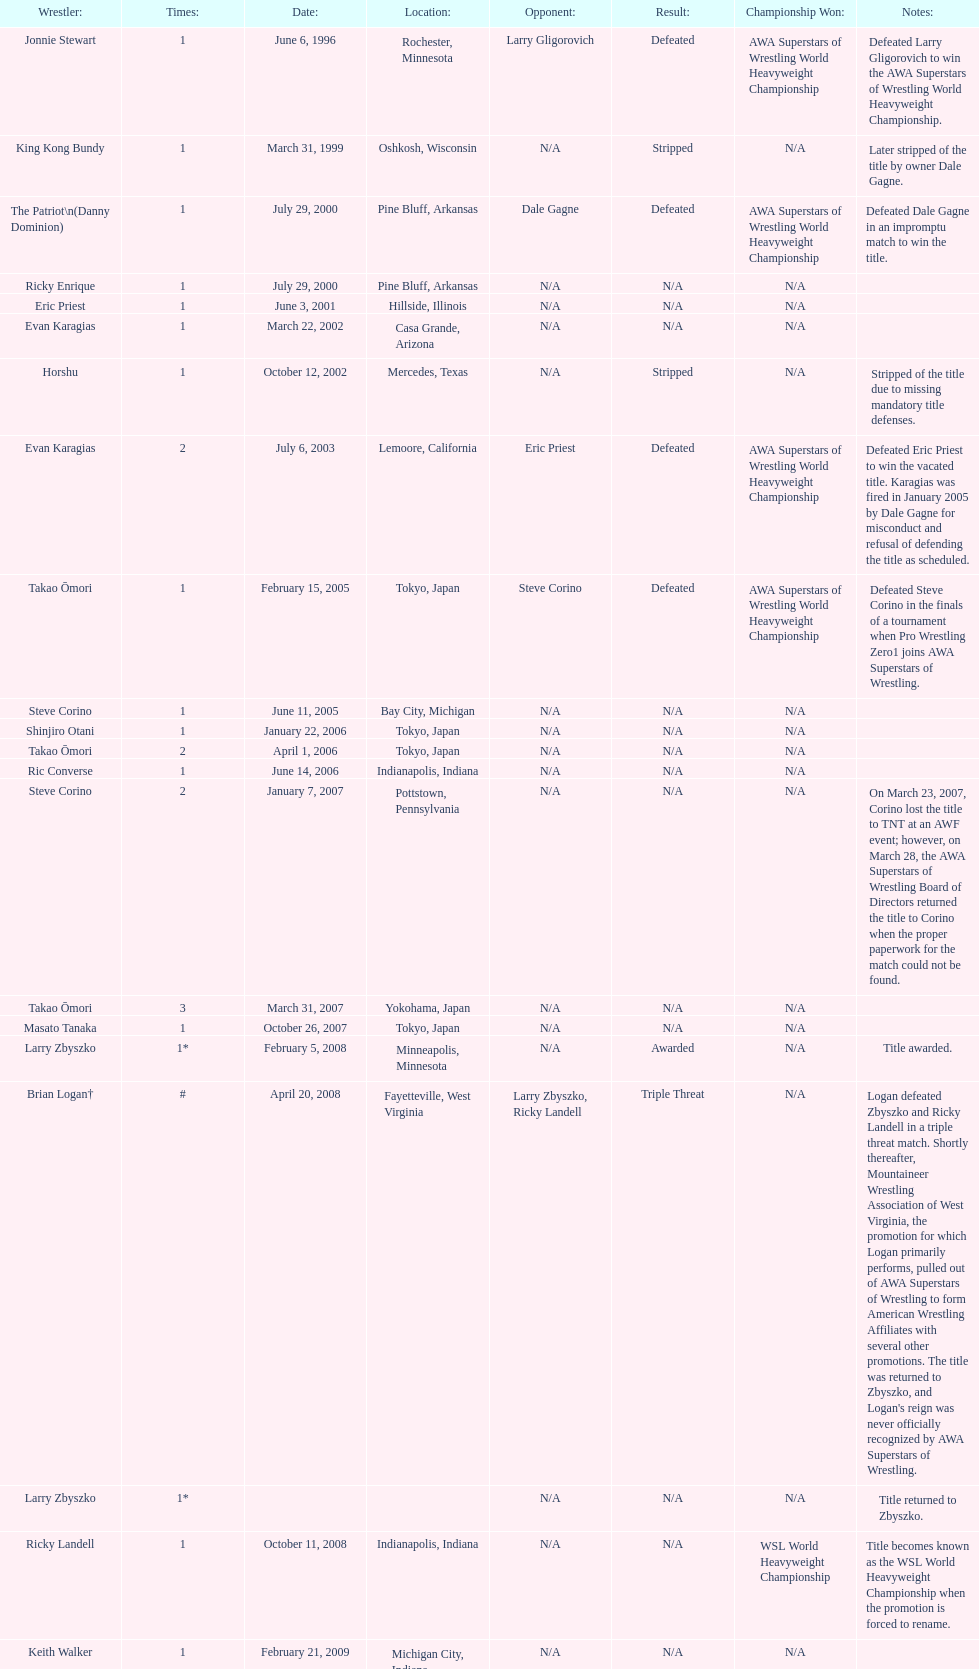How many times has ricky landell held the wsl title? 1. 